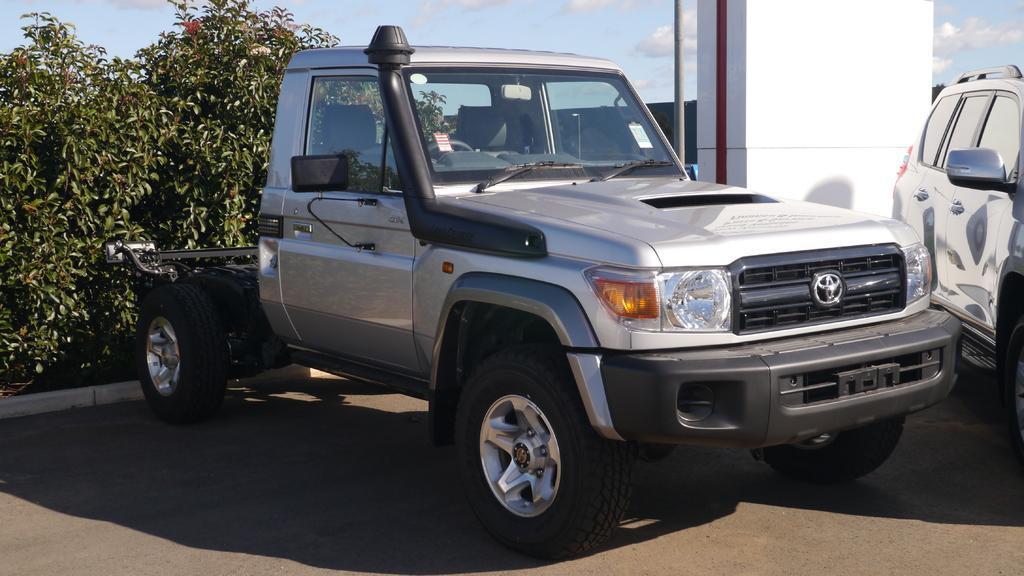Can you describe this image briefly? In this image we can see a car placed on the road. We can also see some plants, pillar, pole and and the sky which looks cloudy. 